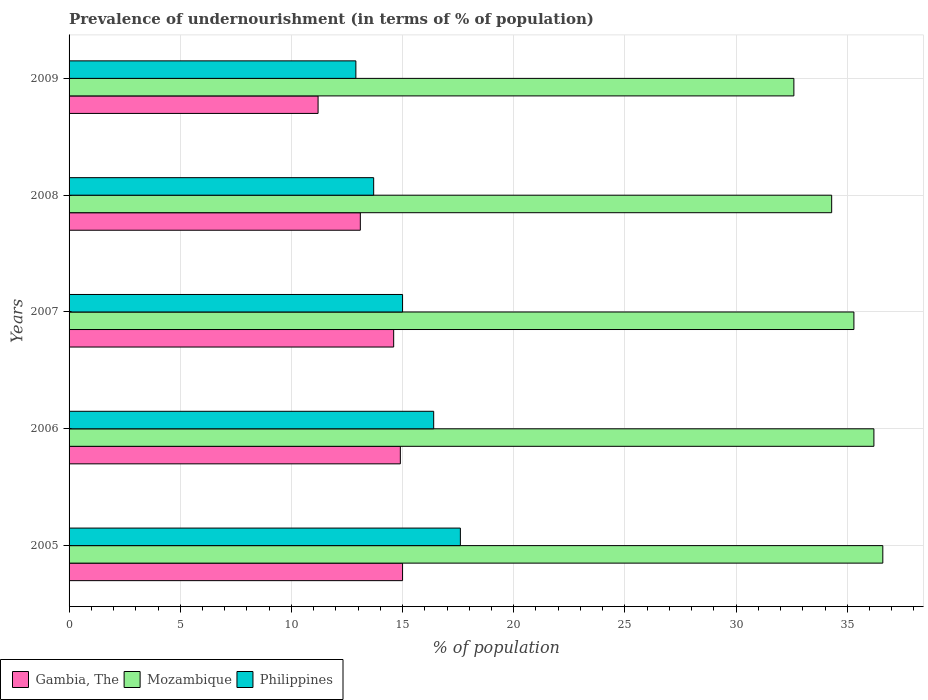How many different coloured bars are there?
Make the answer very short. 3. How many groups of bars are there?
Provide a short and direct response. 5. How many bars are there on the 1st tick from the bottom?
Provide a succinct answer. 3. What is the label of the 5th group of bars from the top?
Keep it short and to the point. 2005. What is the percentage of undernourished population in Philippines in 2005?
Ensure brevity in your answer.  17.6. Across all years, what is the maximum percentage of undernourished population in Mozambique?
Provide a short and direct response. 36.6. Across all years, what is the minimum percentage of undernourished population in Mozambique?
Your answer should be compact. 32.6. In which year was the percentage of undernourished population in Mozambique maximum?
Provide a succinct answer. 2005. What is the total percentage of undernourished population in Mozambique in the graph?
Offer a terse response. 175. What is the difference between the percentage of undernourished population in Mozambique in 2008 and that in 2009?
Your answer should be compact. 1.7. What is the difference between the percentage of undernourished population in Gambia, The in 2006 and the percentage of undernourished population in Mozambique in 2005?
Offer a very short reply. -21.7. What is the average percentage of undernourished population in Mozambique per year?
Your response must be concise. 35. In the year 2009, what is the difference between the percentage of undernourished population in Gambia, The and percentage of undernourished population in Philippines?
Ensure brevity in your answer.  -1.7. In how many years, is the percentage of undernourished population in Gambia, The greater than 14 %?
Your answer should be very brief. 3. What is the ratio of the percentage of undernourished population in Gambia, The in 2008 to that in 2009?
Your answer should be compact. 1.17. Is the percentage of undernourished population in Gambia, The in 2005 less than that in 2009?
Provide a succinct answer. No. What is the difference between the highest and the second highest percentage of undernourished population in Gambia, The?
Make the answer very short. 0.1. What is the difference between the highest and the lowest percentage of undernourished population in Philippines?
Your response must be concise. 4.7. What does the 2nd bar from the top in 2006 represents?
Provide a short and direct response. Mozambique. What does the 2nd bar from the bottom in 2007 represents?
Keep it short and to the point. Mozambique. What is the difference between two consecutive major ticks on the X-axis?
Offer a terse response. 5. How many legend labels are there?
Your answer should be very brief. 3. How are the legend labels stacked?
Give a very brief answer. Horizontal. What is the title of the graph?
Offer a terse response. Prevalence of undernourishment (in terms of % of population). What is the label or title of the X-axis?
Provide a short and direct response. % of population. What is the label or title of the Y-axis?
Offer a very short reply. Years. What is the % of population in Gambia, The in 2005?
Provide a short and direct response. 15. What is the % of population in Mozambique in 2005?
Provide a short and direct response. 36.6. What is the % of population in Philippines in 2005?
Provide a short and direct response. 17.6. What is the % of population in Mozambique in 2006?
Ensure brevity in your answer.  36.2. What is the % of population in Philippines in 2006?
Your response must be concise. 16.4. What is the % of population of Gambia, The in 2007?
Give a very brief answer. 14.6. What is the % of population in Mozambique in 2007?
Provide a short and direct response. 35.3. What is the % of population in Mozambique in 2008?
Offer a terse response. 34.3. What is the % of population in Philippines in 2008?
Your answer should be compact. 13.7. What is the % of population of Gambia, The in 2009?
Provide a succinct answer. 11.2. What is the % of population of Mozambique in 2009?
Provide a short and direct response. 32.6. Across all years, what is the maximum % of population of Gambia, The?
Give a very brief answer. 15. Across all years, what is the maximum % of population of Mozambique?
Make the answer very short. 36.6. Across all years, what is the minimum % of population of Mozambique?
Your response must be concise. 32.6. Across all years, what is the minimum % of population in Philippines?
Ensure brevity in your answer.  12.9. What is the total % of population in Gambia, The in the graph?
Your answer should be compact. 68.8. What is the total % of population of Mozambique in the graph?
Offer a very short reply. 175. What is the total % of population in Philippines in the graph?
Ensure brevity in your answer.  75.6. What is the difference between the % of population of Mozambique in 2005 and that in 2006?
Offer a terse response. 0.4. What is the difference between the % of population of Gambia, The in 2005 and that in 2007?
Your answer should be compact. 0.4. What is the difference between the % of population of Gambia, The in 2005 and that in 2008?
Keep it short and to the point. 1.9. What is the difference between the % of population in Philippines in 2005 and that in 2008?
Make the answer very short. 3.9. What is the difference between the % of population of Gambia, The in 2005 and that in 2009?
Your answer should be compact. 3.8. What is the difference between the % of population of Philippines in 2005 and that in 2009?
Provide a short and direct response. 4.7. What is the difference between the % of population in Gambia, The in 2006 and that in 2007?
Make the answer very short. 0.3. What is the difference between the % of population of Mozambique in 2006 and that in 2007?
Make the answer very short. 0.9. What is the difference between the % of population of Mozambique in 2006 and that in 2008?
Offer a terse response. 1.9. What is the difference between the % of population in Philippines in 2006 and that in 2008?
Ensure brevity in your answer.  2.7. What is the difference between the % of population of Gambia, The in 2006 and that in 2009?
Your response must be concise. 3.7. What is the difference between the % of population in Mozambique in 2006 and that in 2009?
Your response must be concise. 3.6. What is the difference between the % of population of Philippines in 2006 and that in 2009?
Provide a succinct answer. 3.5. What is the difference between the % of population in Mozambique in 2007 and that in 2008?
Your response must be concise. 1. What is the difference between the % of population in Gambia, The in 2007 and that in 2009?
Offer a very short reply. 3.4. What is the difference between the % of population in Mozambique in 2008 and that in 2009?
Provide a succinct answer. 1.7. What is the difference between the % of population of Gambia, The in 2005 and the % of population of Mozambique in 2006?
Your answer should be compact. -21.2. What is the difference between the % of population of Mozambique in 2005 and the % of population of Philippines in 2006?
Your response must be concise. 20.2. What is the difference between the % of population of Gambia, The in 2005 and the % of population of Mozambique in 2007?
Your response must be concise. -20.3. What is the difference between the % of population in Mozambique in 2005 and the % of population in Philippines in 2007?
Keep it short and to the point. 21.6. What is the difference between the % of population in Gambia, The in 2005 and the % of population in Mozambique in 2008?
Your answer should be very brief. -19.3. What is the difference between the % of population in Gambia, The in 2005 and the % of population in Philippines in 2008?
Make the answer very short. 1.3. What is the difference between the % of population in Mozambique in 2005 and the % of population in Philippines in 2008?
Ensure brevity in your answer.  22.9. What is the difference between the % of population of Gambia, The in 2005 and the % of population of Mozambique in 2009?
Provide a succinct answer. -17.6. What is the difference between the % of population in Gambia, The in 2005 and the % of population in Philippines in 2009?
Give a very brief answer. 2.1. What is the difference between the % of population of Mozambique in 2005 and the % of population of Philippines in 2009?
Provide a succinct answer. 23.7. What is the difference between the % of population in Gambia, The in 2006 and the % of population in Mozambique in 2007?
Your answer should be very brief. -20.4. What is the difference between the % of population in Gambia, The in 2006 and the % of population in Philippines in 2007?
Offer a very short reply. -0.1. What is the difference between the % of population of Mozambique in 2006 and the % of population of Philippines in 2007?
Make the answer very short. 21.2. What is the difference between the % of population of Gambia, The in 2006 and the % of population of Mozambique in 2008?
Offer a very short reply. -19.4. What is the difference between the % of population of Gambia, The in 2006 and the % of population of Philippines in 2008?
Your response must be concise. 1.2. What is the difference between the % of population of Gambia, The in 2006 and the % of population of Mozambique in 2009?
Keep it short and to the point. -17.7. What is the difference between the % of population in Mozambique in 2006 and the % of population in Philippines in 2009?
Offer a terse response. 23.3. What is the difference between the % of population in Gambia, The in 2007 and the % of population in Mozambique in 2008?
Your answer should be compact. -19.7. What is the difference between the % of population of Mozambique in 2007 and the % of population of Philippines in 2008?
Provide a short and direct response. 21.6. What is the difference between the % of population of Mozambique in 2007 and the % of population of Philippines in 2009?
Provide a short and direct response. 22.4. What is the difference between the % of population in Gambia, The in 2008 and the % of population in Mozambique in 2009?
Make the answer very short. -19.5. What is the difference between the % of population in Gambia, The in 2008 and the % of population in Philippines in 2009?
Your answer should be very brief. 0.2. What is the difference between the % of population of Mozambique in 2008 and the % of population of Philippines in 2009?
Provide a succinct answer. 21.4. What is the average % of population of Gambia, The per year?
Offer a very short reply. 13.76. What is the average % of population in Mozambique per year?
Make the answer very short. 35. What is the average % of population of Philippines per year?
Ensure brevity in your answer.  15.12. In the year 2005, what is the difference between the % of population in Gambia, The and % of population in Mozambique?
Offer a terse response. -21.6. In the year 2006, what is the difference between the % of population of Gambia, The and % of population of Mozambique?
Your answer should be very brief. -21.3. In the year 2006, what is the difference between the % of population of Mozambique and % of population of Philippines?
Provide a short and direct response. 19.8. In the year 2007, what is the difference between the % of population in Gambia, The and % of population in Mozambique?
Offer a very short reply. -20.7. In the year 2007, what is the difference between the % of population in Mozambique and % of population in Philippines?
Offer a terse response. 20.3. In the year 2008, what is the difference between the % of population of Gambia, The and % of population of Mozambique?
Provide a short and direct response. -21.2. In the year 2008, what is the difference between the % of population of Gambia, The and % of population of Philippines?
Your answer should be very brief. -0.6. In the year 2008, what is the difference between the % of population in Mozambique and % of population in Philippines?
Give a very brief answer. 20.6. In the year 2009, what is the difference between the % of population in Gambia, The and % of population in Mozambique?
Give a very brief answer. -21.4. In the year 2009, what is the difference between the % of population in Gambia, The and % of population in Philippines?
Keep it short and to the point. -1.7. What is the ratio of the % of population in Gambia, The in 2005 to that in 2006?
Offer a terse response. 1.01. What is the ratio of the % of population of Philippines in 2005 to that in 2006?
Offer a very short reply. 1.07. What is the ratio of the % of population in Gambia, The in 2005 to that in 2007?
Your answer should be very brief. 1.03. What is the ratio of the % of population in Mozambique in 2005 to that in 2007?
Provide a short and direct response. 1.04. What is the ratio of the % of population of Philippines in 2005 to that in 2007?
Your answer should be compact. 1.17. What is the ratio of the % of population in Gambia, The in 2005 to that in 2008?
Keep it short and to the point. 1.15. What is the ratio of the % of population of Mozambique in 2005 to that in 2008?
Make the answer very short. 1.07. What is the ratio of the % of population of Philippines in 2005 to that in 2008?
Provide a short and direct response. 1.28. What is the ratio of the % of population of Gambia, The in 2005 to that in 2009?
Your answer should be very brief. 1.34. What is the ratio of the % of population in Mozambique in 2005 to that in 2009?
Provide a succinct answer. 1.12. What is the ratio of the % of population in Philippines in 2005 to that in 2009?
Provide a succinct answer. 1.36. What is the ratio of the % of population in Gambia, The in 2006 to that in 2007?
Give a very brief answer. 1.02. What is the ratio of the % of population in Mozambique in 2006 to that in 2007?
Your answer should be very brief. 1.03. What is the ratio of the % of population of Philippines in 2006 to that in 2007?
Offer a terse response. 1.09. What is the ratio of the % of population of Gambia, The in 2006 to that in 2008?
Provide a short and direct response. 1.14. What is the ratio of the % of population in Mozambique in 2006 to that in 2008?
Give a very brief answer. 1.06. What is the ratio of the % of population in Philippines in 2006 to that in 2008?
Make the answer very short. 1.2. What is the ratio of the % of population in Gambia, The in 2006 to that in 2009?
Make the answer very short. 1.33. What is the ratio of the % of population in Mozambique in 2006 to that in 2009?
Offer a terse response. 1.11. What is the ratio of the % of population of Philippines in 2006 to that in 2009?
Ensure brevity in your answer.  1.27. What is the ratio of the % of population of Gambia, The in 2007 to that in 2008?
Provide a succinct answer. 1.11. What is the ratio of the % of population in Mozambique in 2007 to that in 2008?
Keep it short and to the point. 1.03. What is the ratio of the % of population in Philippines in 2007 to that in 2008?
Your response must be concise. 1.09. What is the ratio of the % of population in Gambia, The in 2007 to that in 2009?
Provide a short and direct response. 1.3. What is the ratio of the % of population of Mozambique in 2007 to that in 2009?
Your answer should be compact. 1.08. What is the ratio of the % of population in Philippines in 2007 to that in 2009?
Your answer should be very brief. 1.16. What is the ratio of the % of population of Gambia, The in 2008 to that in 2009?
Give a very brief answer. 1.17. What is the ratio of the % of population of Mozambique in 2008 to that in 2009?
Offer a very short reply. 1.05. What is the ratio of the % of population in Philippines in 2008 to that in 2009?
Ensure brevity in your answer.  1.06. What is the difference between the highest and the second highest % of population of Gambia, The?
Your answer should be compact. 0.1. What is the difference between the highest and the second highest % of population in Philippines?
Make the answer very short. 1.2. 